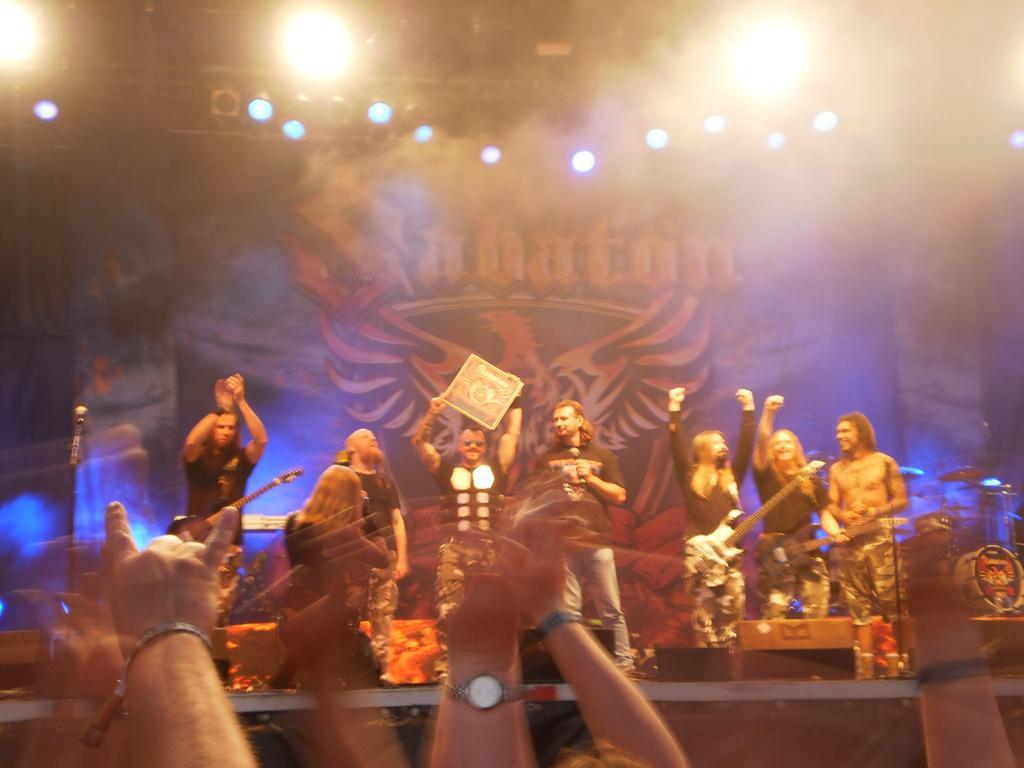In one or two sentences, can you explain what this image depicts? In this picture there is a music band on the stage, holding a musical instruments in their hands. There are some people hands from the down. In the background there is a poster and some lights here. 